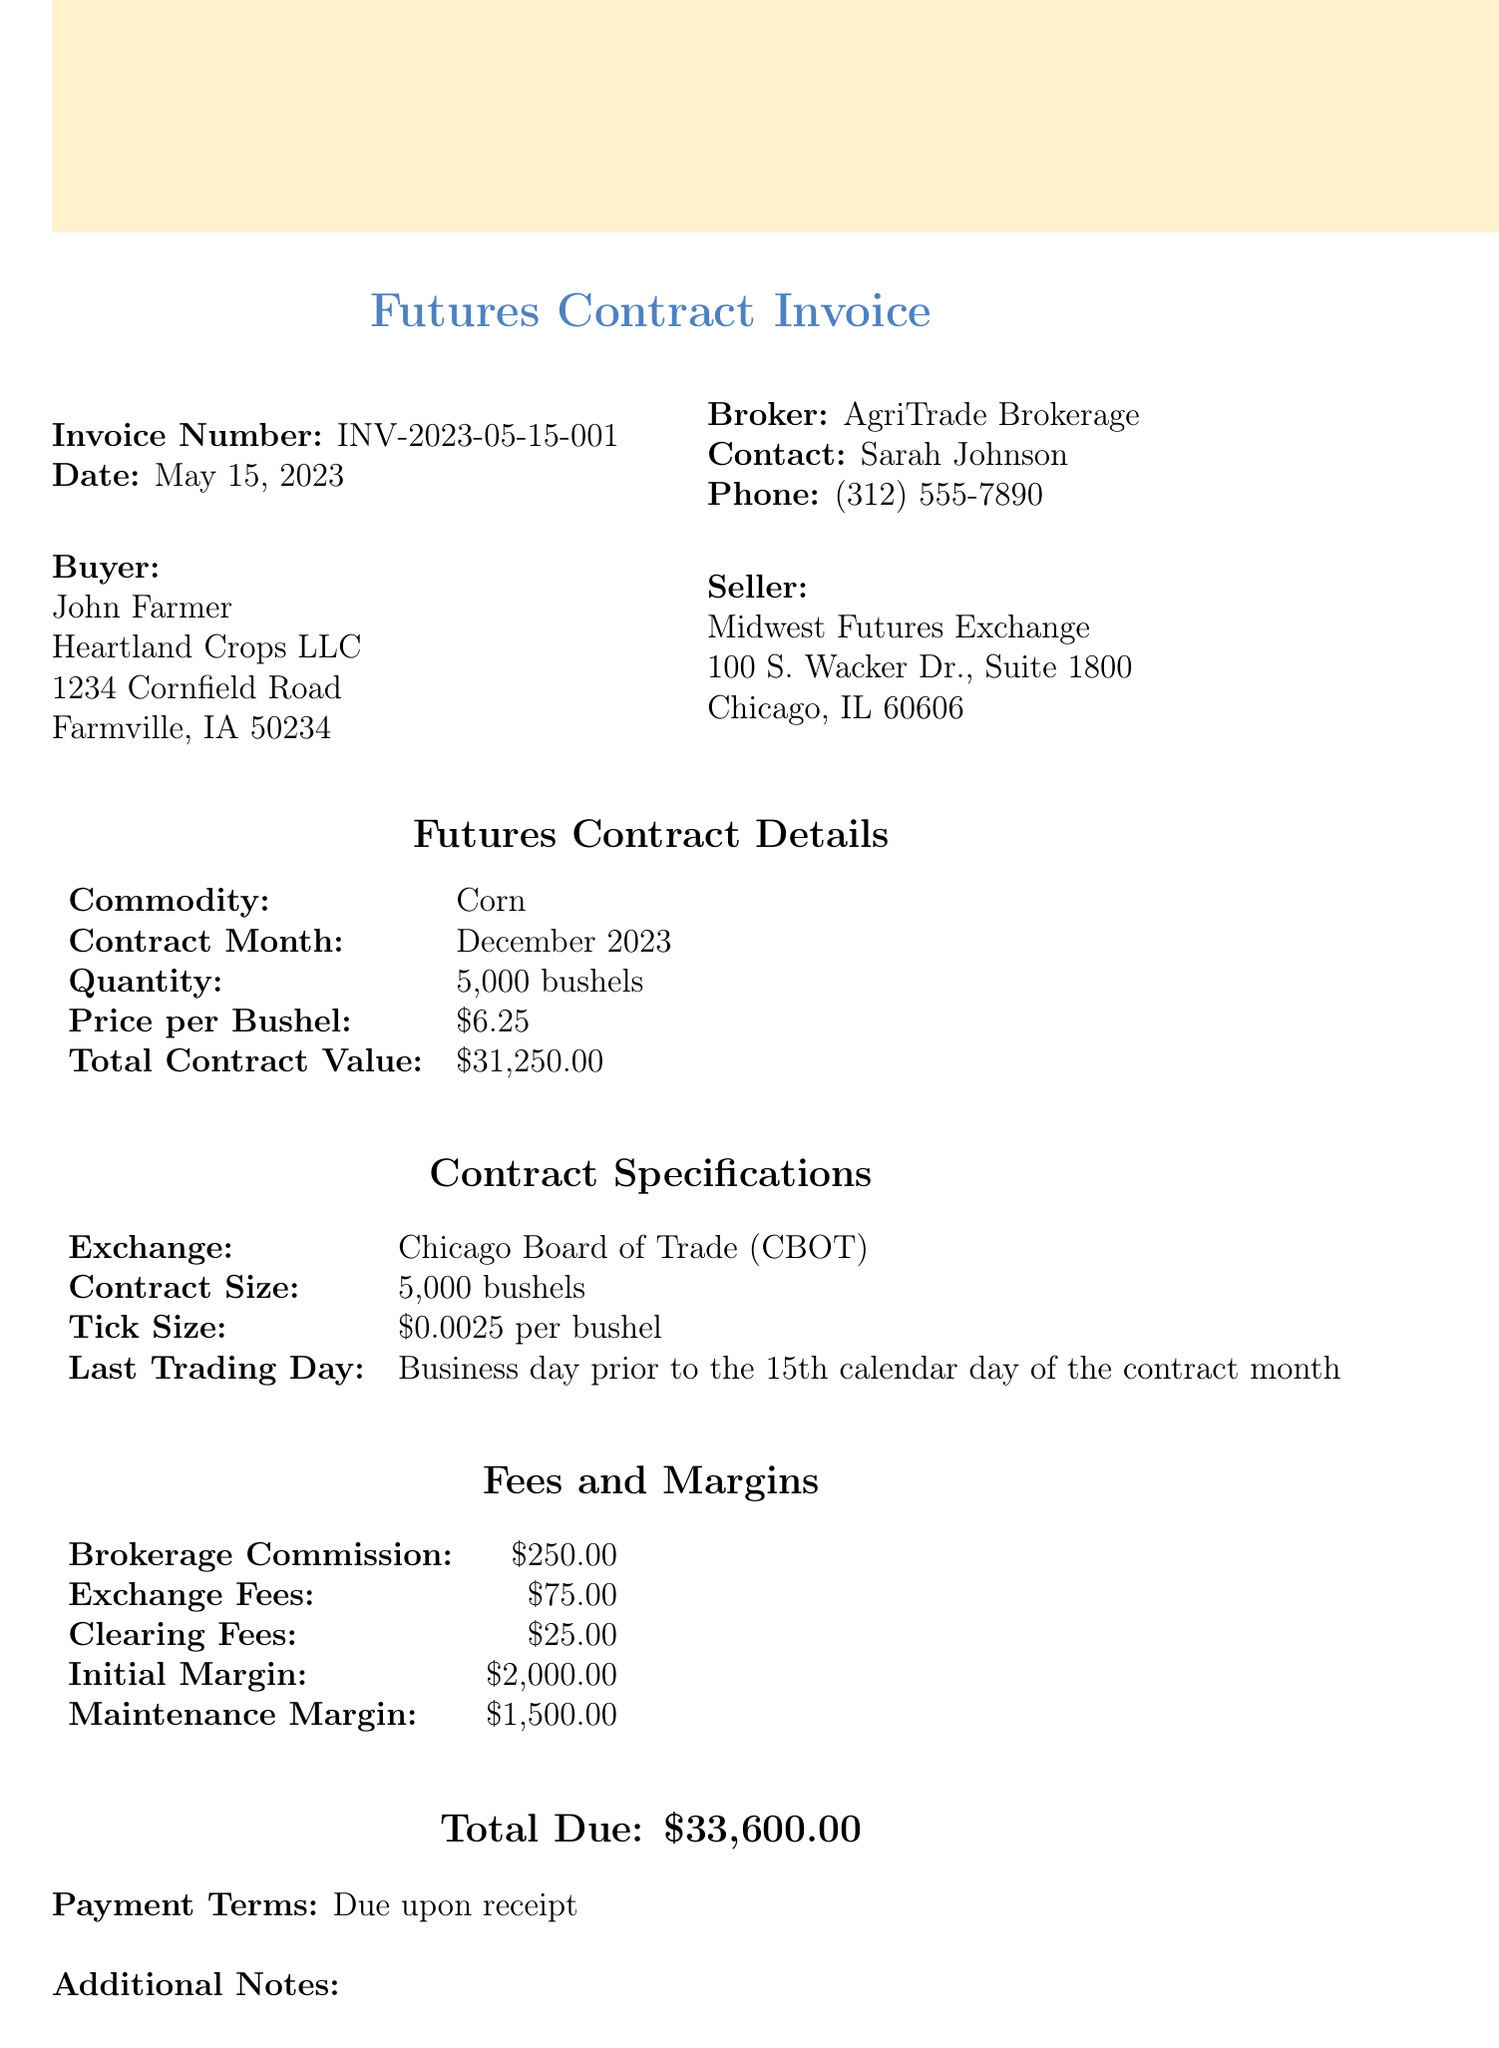What is the invoice number? The invoice number is listed at the top of the document under "Invoice Number."
Answer: INV-2023-05-15-001 What is the date of the invoice? The date is specified near the invoice number section.
Answer: May 15, 2023 Who is the buyer? The buyer details are mentioned in the "Buyer" section, including the name and company.
Answer: John Farmer, Heartland Crops LLC What is the total contract value? The total contract value can be found in the futures contract details.
Answer: $31,250.00 What is the initial margin requirement? The initial margin is listed under the "Fees and Margins" section of the document.
Answer: $2,000.00 What is the last trading day for the contract? The last trading day is specified in the contract specifications section.
Answer: Business day prior to the 15th calendar day of the contract month What are the brokerage commission fees? The brokerage commission is listed in the "Fees and Margins" section.
Answer: $250.00 What is the commodity for this futures contract? The commodity is stated in the futures contract details section of the document.
Answer: Corn Why is this futures contract being purchased? The purpose of the contract is mentioned in the additional notes section.
Answer: To hedge against corn price fluctuations for the upcoming harvest season 